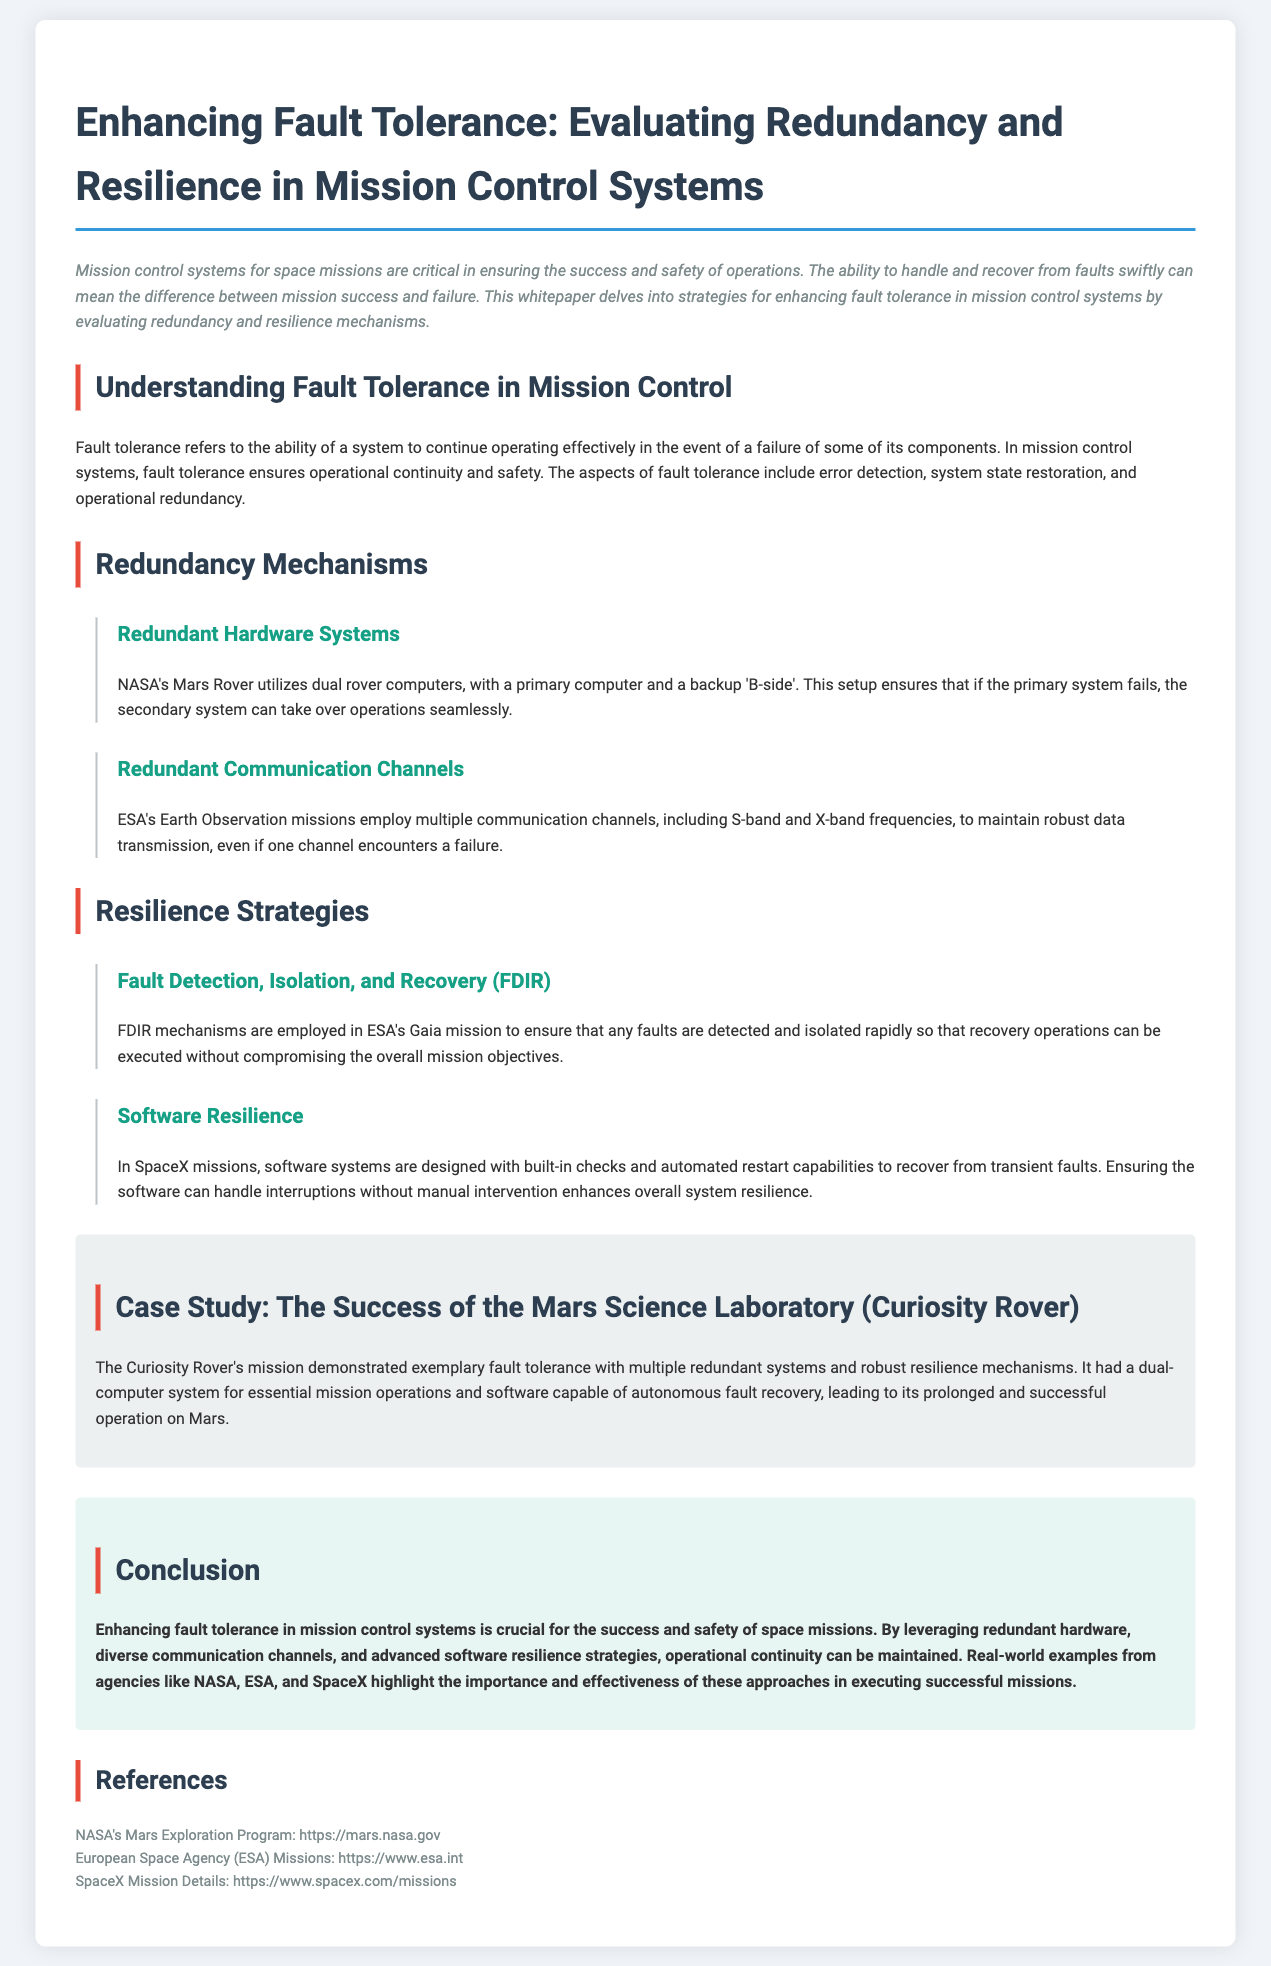what is the title of the whitepaper? The title of the whitepaper is stated prominently at the top of the document.
Answer: Enhancing Fault Tolerance: Evaluating Redundancy and Resilience in Mission Control Systems what mission does NASA's Mars Rover utilize for redundancy? The mission involves a dual computer system designed to enhance reliability in operations.
Answer: dual rover computers which communication channels does ESA's Earth Observation use? The document specifies the types of communication channels using examples to elaborate on redundancy.
Answer: S-band and X-band frequencies what strategy does ESA's Gaia mission employ for fault handling? FDIR is a specific mechanism mentioned for rapid fault detection and recovery in the mission.
Answer: Fault Detection, Isolation, and Recovery (FDIR) how many redundant systems did the Curiosity Rover have for operations? The Curiosity Rover's mission highlighted its structured approach to fault tolerance and resilience.
Answer: multiple redundant systems what type of resilience is emphasized in SpaceX missions? The document describes software capabilities that allow for specific recovery actions during operations.
Answer: built-in checks and automated restart capabilities who provided the references for the whitepaper? The references are sourced from established space agencies and companies involved in space missions.
Answer: NASA, ESA, SpaceX what is the key benefit of enhancing fault tolerance in mission control systems? The whitepaper articulates the importance of operational continuity and safety in space missions.
Answer: success and safety of space missions 